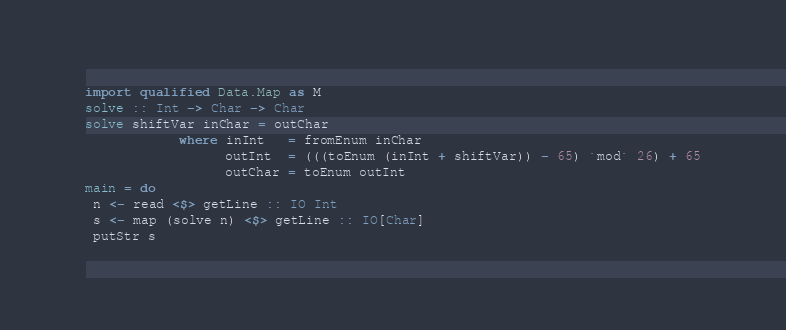<code> <loc_0><loc_0><loc_500><loc_500><_Haskell_>import qualified Data.Map as M
solve :: Int -> Char -> Char 
solve shiftVar inChar = outChar
            where inInt   = fromEnum inChar
                  outInt  = (((toEnum (inInt + shiftVar)) - 65) `mod` 26) + 65
                  outChar = toEnum outInt
main = do
 n <- read <$> getLine :: IO Int
 s <- map (solve n) <$> getLine :: IO[Char]
 putStr s</code> 